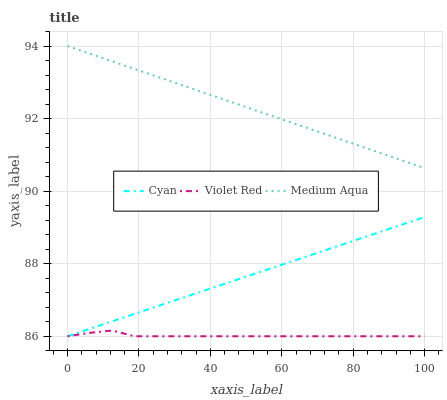Does Violet Red have the minimum area under the curve?
Answer yes or no. Yes. Does Medium Aqua have the maximum area under the curve?
Answer yes or no. Yes. Does Medium Aqua have the minimum area under the curve?
Answer yes or no. No. Does Violet Red have the maximum area under the curve?
Answer yes or no. No. Is Medium Aqua the smoothest?
Answer yes or no. Yes. Is Violet Red the roughest?
Answer yes or no. Yes. Is Violet Red the smoothest?
Answer yes or no. No. Is Medium Aqua the roughest?
Answer yes or no. No. Does Cyan have the lowest value?
Answer yes or no. Yes. Does Medium Aqua have the lowest value?
Answer yes or no. No. Does Medium Aqua have the highest value?
Answer yes or no. Yes. Does Violet Red have the highest value?
Answer yes or no. No. Is Cyan less than Medium Aqua?
Answer yes or no. Yes. Is Medium Aqua greater than Violet Red?
Answer yes or no. Yes. Does Cyan intersect Violet Red?
Answer yes or no. Yes. Is Cyan less than Violet Red?
Answer yes or no. No. Is Cyan greater than Violet Red?
Answer yes or no. No. Does Cyan intersect Medium Aqua?
Answer yes or no. No. 